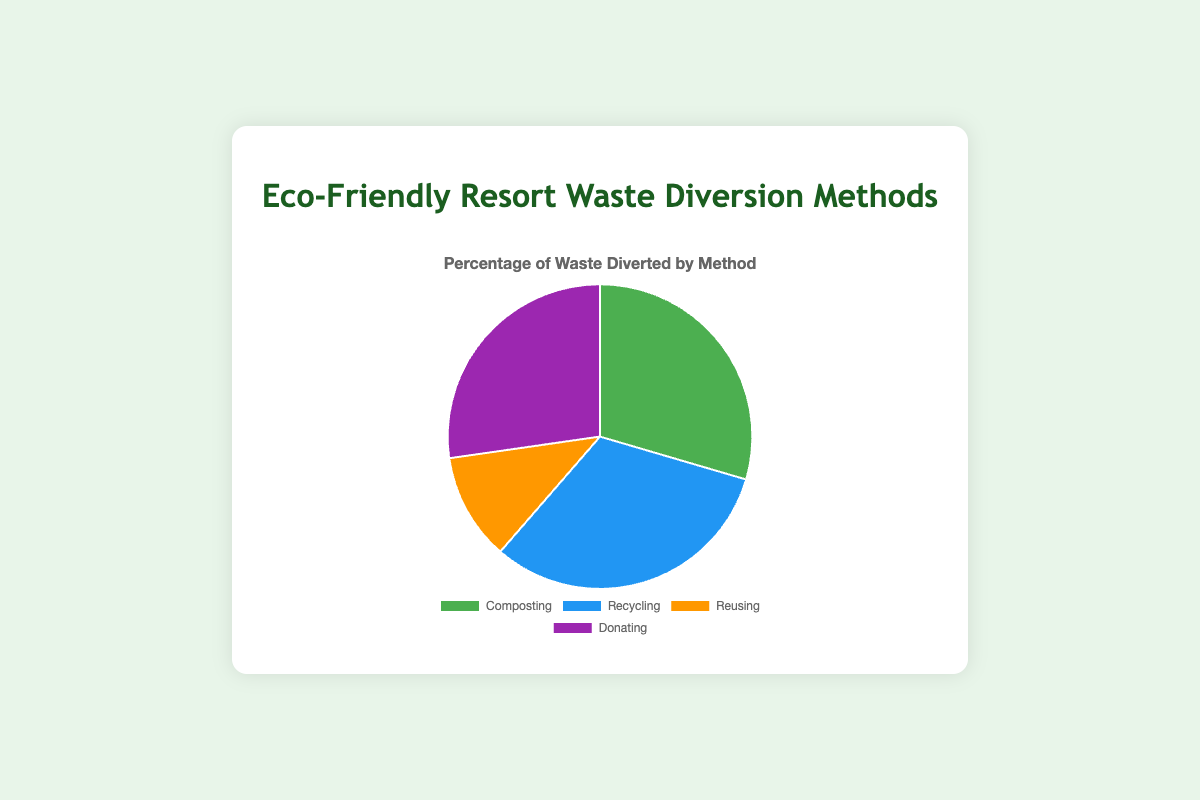What method has the highest percentage of waste diversion? Look at the chart and identify the method with the largest portion. Recycling has the highest percentage with 70%.
Answer: Recycling What is the combined percentage of waste diversion for Composting and Donating? Add the percentages of Composting and Donating: 65% + 60% = 125%.
Answer: 125% Which method diverts more waste, Reusing or Donating? Compare the percentages of Reusing (25%) and Donating (60%). Donating has a higher percentage.
Answer: Donating How much more waste is diverted by Recycling compared to Reusing? Subtract the percentage of Reusing from Recycling: 70% - 25% = 45%.
Answer: 45% What percentage of waste is diverted by methods other than Composting? Subtract the percentage of Composting from 100%: 100% - 65% = 35%.
Answer: 35% Which waste diversion method is represented by the green segment? Refer to the color of the segments in the chart. The green segment represents Composting.
Answer: Composting Are the percentages of waste diversion by Composting and Donating together more than double the percentage of Reusing? Calculate double the percentage of Reusing: 2 * 25% = 50%. Add the percentages of Composting and Donating: 65% + 60% = 125%. Compare 125% to 50%. Yes, they are more than double.
Answer: Yes If you combined the percentages of Food Waste across all methods, what would it be? Add the percentages of Kitchen Food Waste (40%) in Composting and Unconsumed Food (25%) in Donating. 40% + 25% = 65%.
Answer: 65% How much lower is the percentage of waste diversion by Composting compared to the sum of Recycling, Reusing, and Donating? First, sum the percentages of Recycling, Reusing, and Donating: 70% + 25% + 60% = 155%. Then subtract the percentage of Composting: 155% - 65% = 90%.
Answer: 90% What percentage of waste is diverted by Composting from the primary sources (Kitchen Food Waste and Garden Waste)? Add the percentages of Kitchen Food Waste (40%) and Garden Waste (25%): 40% + 25% = 65%.
Answer: 65% 